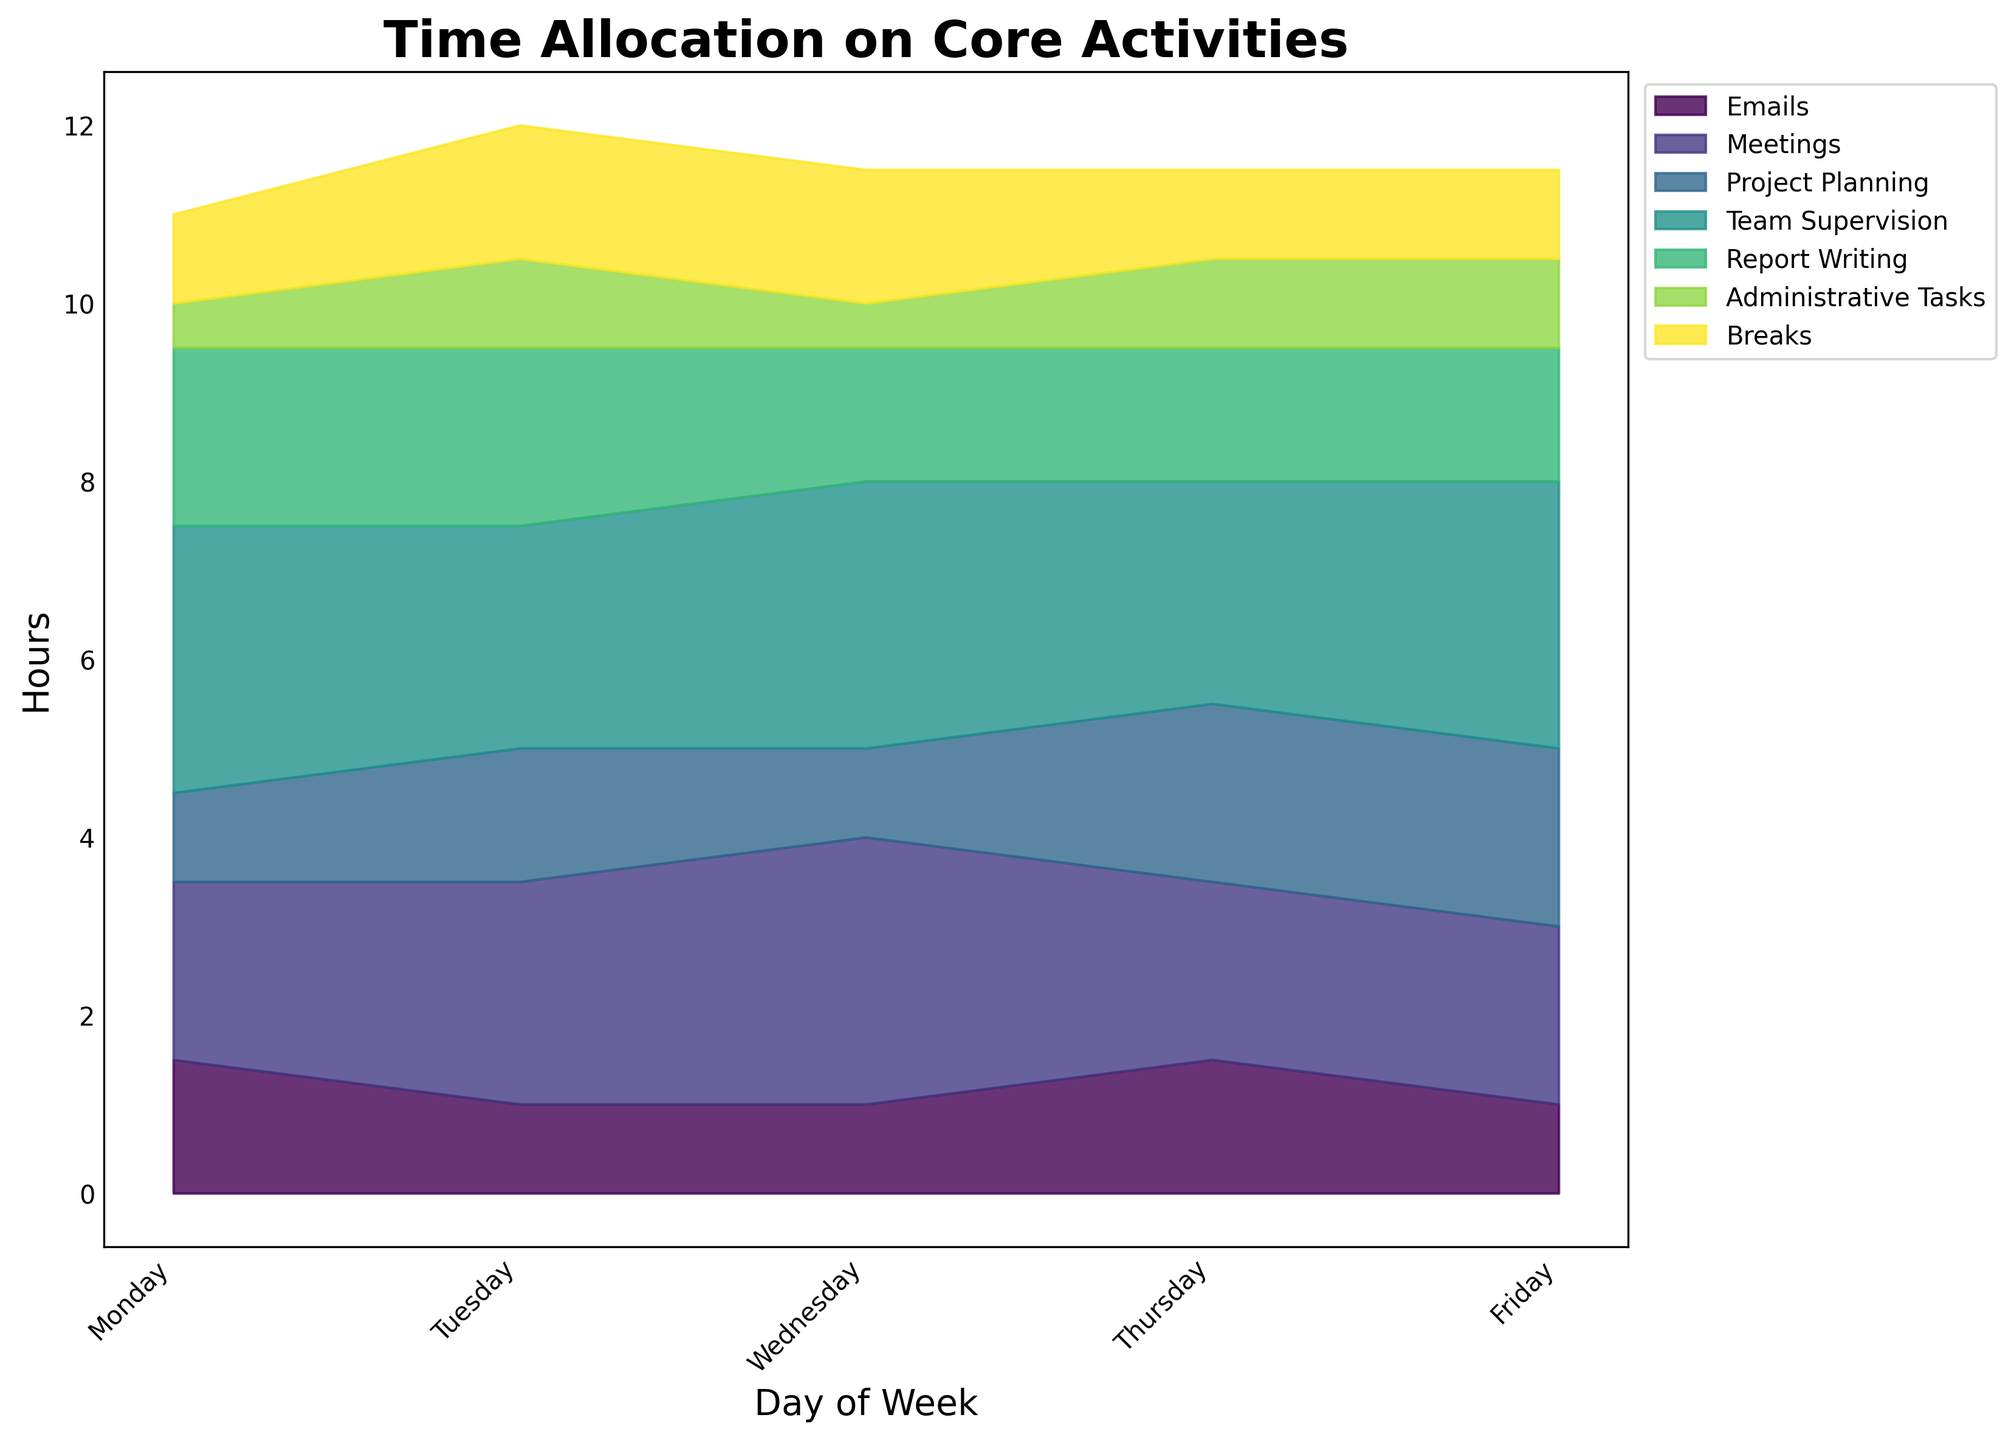What is the title of the figure? The title is positioned at the top of the figure, usually in larger and bold font to stand out. By looking at this area, you can identify that it reads "Time Allocation on Core Activities".
Answer: Time Allocation on Core Activities Which day of the week has the maximum total hours allocated to activities? By analyzing the total height of the stacked area for each day, Friday shows the maximum overall height, indicating the most total hours allocated to activities.
Answer: Friday What is the total number of hours allocated to Administrative Tasks on Tuesday? By locating the section corresponding to "Administrative Tasks" on Tuesday, and reading the value directly from the plot, you can see that it is 1 hour.
Answer: 1 hour Which task category has the largest allocation of hours on Wednesday? By examining the relative sizes of the different colored areas on Wednesday, "Team Supervision" has the largest section, making it the task category with the highest allocation of hours.
Answer: Team Supervision Compare the time spent on meetings between Monday and Wednesday. Which day has more hours allocated? By looking at the sections for "Meetings" on both Monday and Wednesday, you can see that Wednesday has a larger area, indicating more hours spent on meetings on that day.
Answer: Wednesday On which day is the least amount of time spent on breaks? By comparing the size of the sections designated for "Breaks" across all days, you can see that Monday and Thursday have the smallest sections, indicating the least amount of time spent on breaks, which is 1 hour.
Answer: Monday and Thursday How many more hours are allocated to Project Planning on Friday compared to Monday? The allocation for Project Planning on Friday is 2 hours, and on Monday, it is 1 hour. By subtracting, we find that Friday has 1 more hour allocated to Project Planning compared to Monday.
Answer: 1 hour What is the average number of hours allocated to Report Writing across the five days? By summing the hours allocated to Report Writing across each day (2 + 2 + 1.5 + 1.5 + 1.5) = 8.5 hours, and dividing by 5 days, the average is 1.7 hours.
Answer: 1.7 hours Which day has the smallest allocation for Emails, and what is the value? By comparing the sections for "Emails" across all days, Monday, Tuesday, Wednesday, and Friday all have 1 hour allocated, which is the smallest.
Answer: Monday, Tuesday, Wednesday, and Friday 